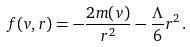Convert formula to latex. <formula><loc_0><loc_0><loc_500><loc_500>f ( v , r ) = - \frac { 2 m ( v ) } { r ^ { 2 } } - \frac { \Lambda } { 6 } r ^ { 2 } \, .</formula> 